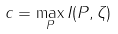Convert formula to latex. <formula><loc_0><loc_0><loc_500><loc_500>c = \max _ { P } I ( P , \zeta )</formula> 